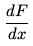Convert formula to latex. <formula><loc_0><loc_0><loc_500><loc_500>\frac { d F } { d x }</formula> 